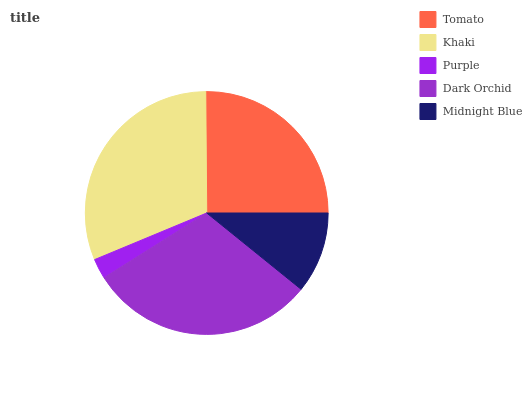Is Purple the minimum?
Answer yes or no. Yes. Is Khaki the maximum?
Answer yes or no. Yes. Is Khaki the minimum?
Answer yes or no. No. Is Purple the maximum?
Answer yes or no. No. Is Khaki greater than Purple?
Answer yes or no. Yes. Is Purple less than Khaki?
Answer yes or no. Yes. Is Purple greater than Khaki?
Answer yes or no. No. Is Khaki less than Purple?
Answer yes or no. No. Is Tomato the high median?
Answer yes or no. Yes. Is Tomato the low median?
Answer yes or no. Yes. Is Dark Orchid the high median?
Answer yes or no. No. Is Khaki the low median?
Answer yes or no. No. 